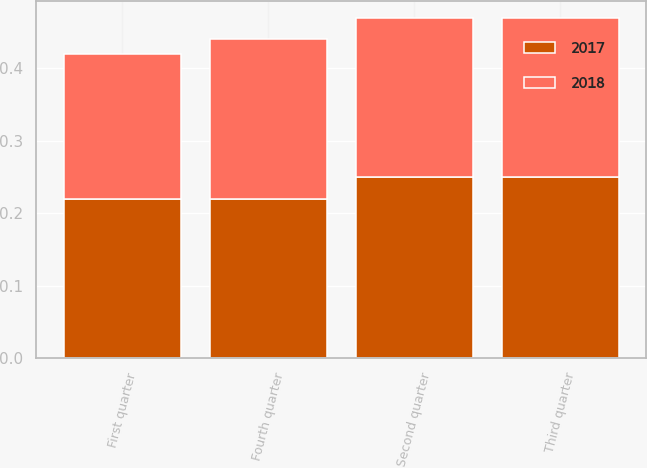<chart> <loc_0><loc_0><loc_500><loc_500><stacked_bar_chart><ecel><fcel>First quarter<fcel>Second quarter<fcel>Third quarter<fcel>Fourth quarter<nl><fcel>2017<fcel>0.22<fcel>0.25<fcel>0.25<fcel>0.22<nl><fcel>2018<fcel>0.2<fcel>0.22<fcel>0.22<fcel>0.22<nl></chart> 